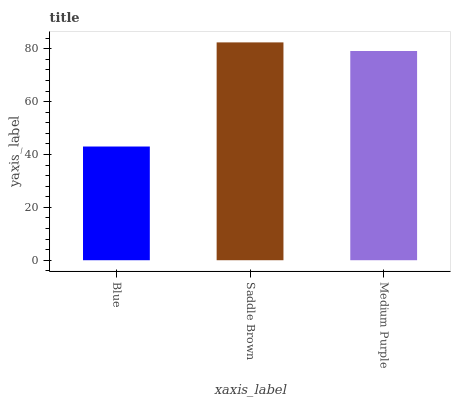Is Blue the minimum?
Answer yes or no. Yes. Is Saddle Brown the maximum?
Answer yes or no. Yes. Is Medium Purple the minimum?
Answer yes or no. No. Is Medium Purple the maximum?
Answer yes or no. No. Is Saddle Brown greater than Medium Purple?
Answer yes or no. Yes. Is Medium Purple less than Saddle Brown?
Answer yes or no. Yes. Is Medium Purple greater than Saddle Brown?
Answer yes or no. No. Is Saddle Brown less than Medium Purple?
Answer yes or no. No. Is Medium Purple the high median?
Answer yes or no. Yes. Is Medium Purple the low median?
Answer yes or no. Yes. Is Saddle Brown the high median?
Answer yes or no. No. Is Blue the low median?
Answer yes or no. No. 